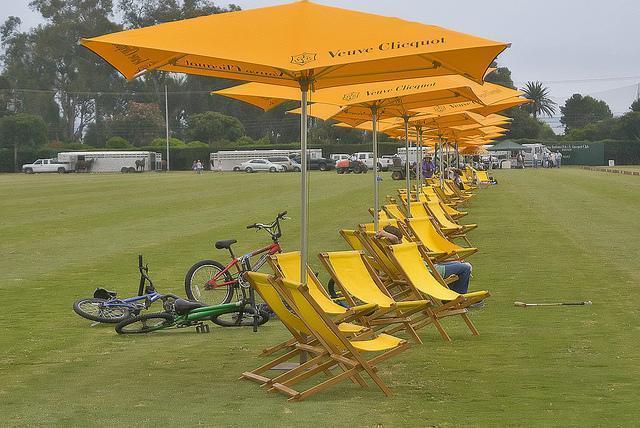The sporting event taking place on the grounds is most likely which one?
Indicate the correct response and explain using: 'Answer: answer
Rationale: rationale.'
Options: Golf, swimming, tennis, cycling. Answer: golf.
Rationale: The chairs are on a golf course. 